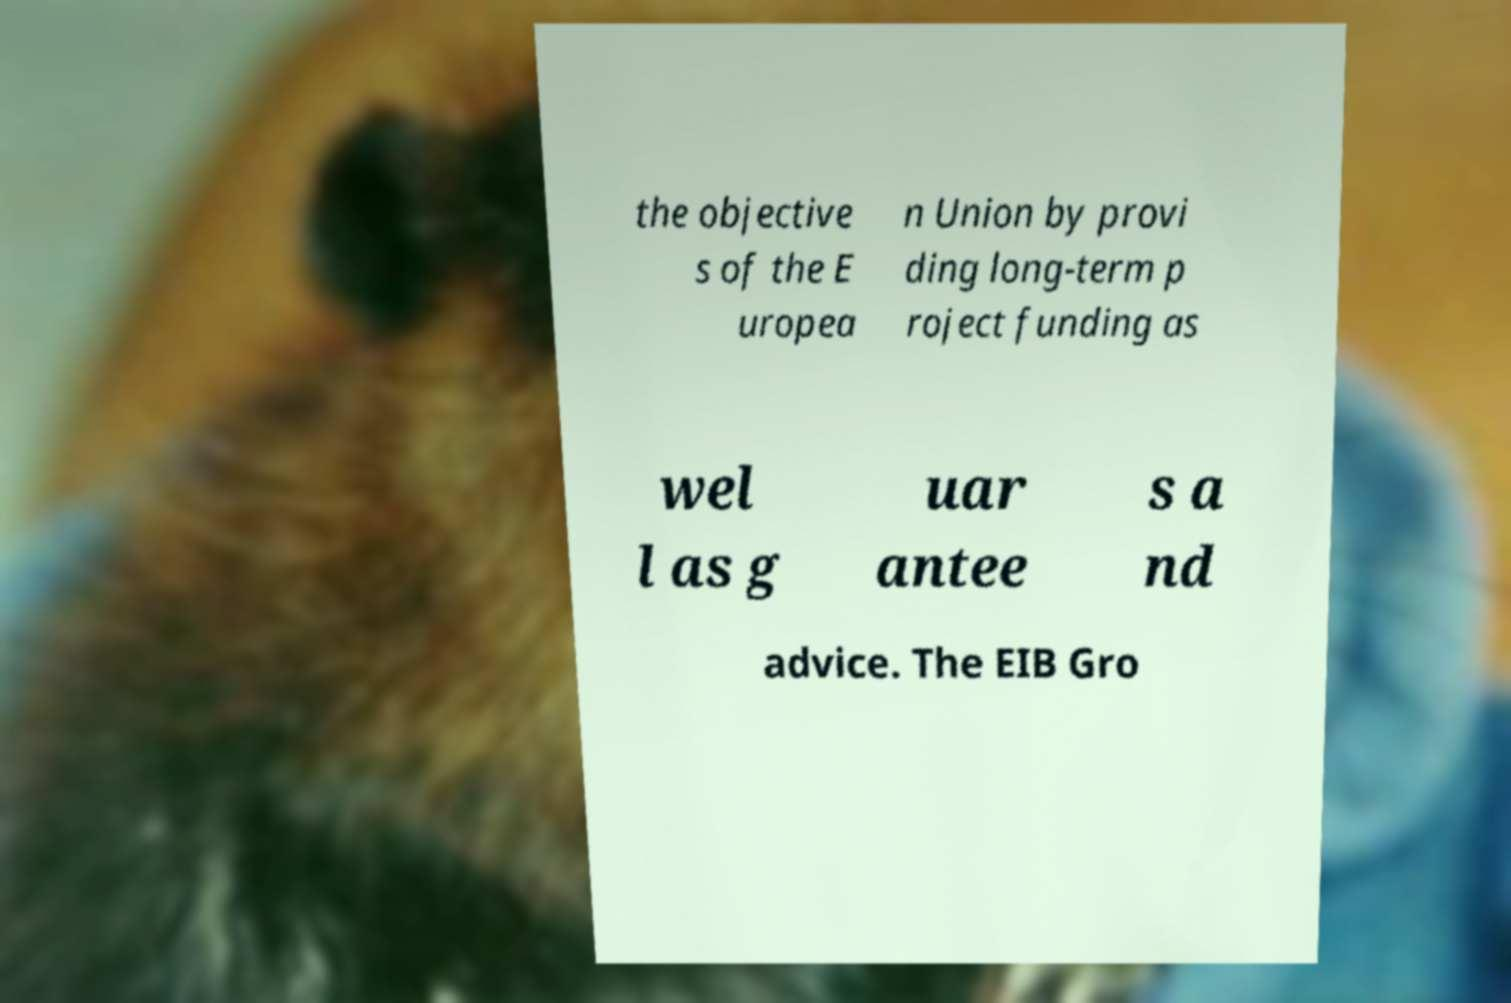Please read and relay the text visible in this image. What does it say? the objective s of the E uropea n Union by provi ding long-term p roject funding as wel l as g uar antee s a nd advice. The EIB Gro 